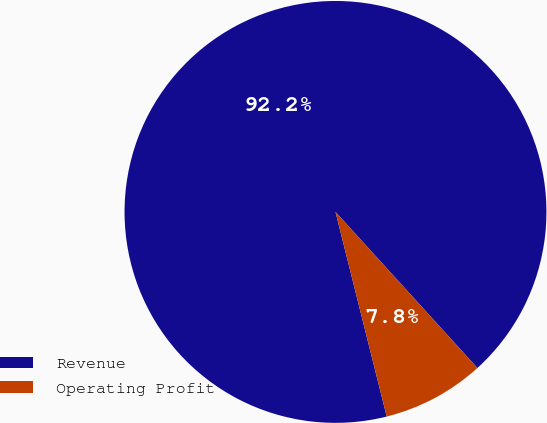Convert chart. <chart><loc_0><loc_0><loc_500><loc_500><pie_chart><fcel>Revenue<fcel>Operating Profit<nl><fcel>92.16%<fcel>7.84%<nl></chart> 